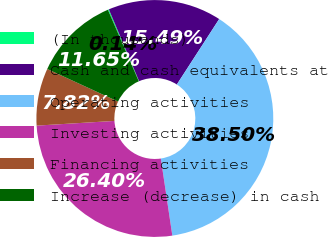<chart> <loc_0><loc_0><loc_500><loc_500><pie_chart><fcel>(In thousands)<fcel>Cash and cash equivalents at<fcel>Operating activities<fcel>Investing activities<fcel>Financing activities<fcel>Increase (decrease) in cash<nl><fcel>0.14%<fcel>15.49%<fcel>38.5%<fcel>26.4%<fcel>7.82%<fcel>11.65%<nl></chart> 